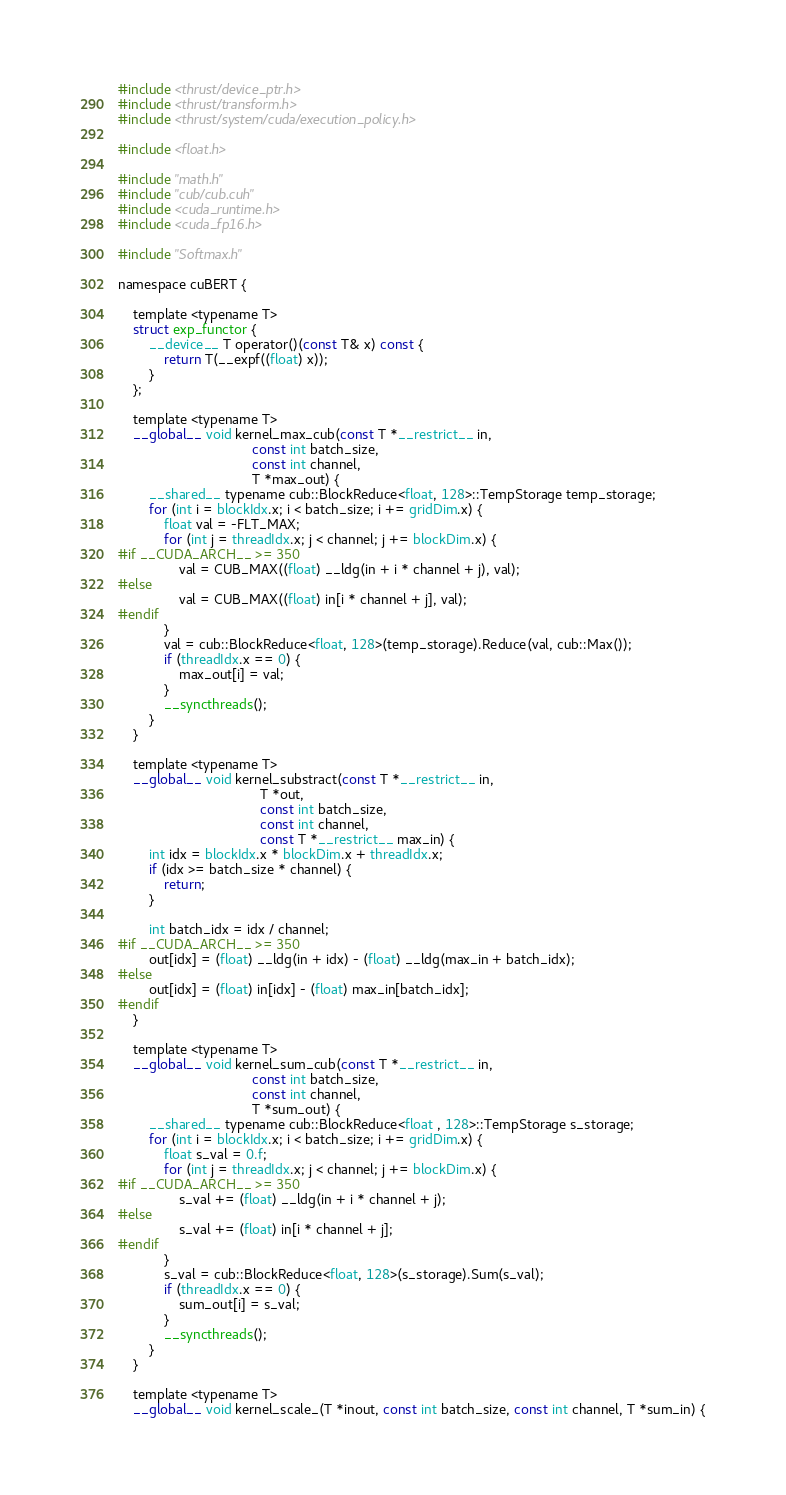<code> <loc_0><loc_0><loc_500><loc_500><_Cuda_>#include <thrust/device_ptr.h>
#include <thrust/transform.h>
#include <thrust/system/cuda/execution_policy.h>

#include <float.h>

#include "math.h"
#include "cub/cub.cuh"
#include <cuda_runtime.h>
#include <cuda_fp16.h>

#include "Softmax.h"

namespace cuBERT {

    template <typename T>
    struct exp_functor {
        __device__ T operator()(const T& x) const {
            return T(__expf((float) x));
        }
    };

    template <typename T>
    __global__ void kernel_max_cub(const T *__restrict__ in,
                                   const int batch_size,
                                   const int channel,
                                   T *max_out) {
        __shared__ typename cub::BlockReduce<float, 128>::TempStorage temp_storage;
        for (int i = blockIdx.x; i < batch_size; i += gridDim.x) {
            float val = -FLT_MAX;
            for (int j = threadIdx.x; j < channel; j += blockDim.x) {
#if __CUDA_ARCH__ >= 350
                val = CUB_MAX((float) __ldg(in + i * channel + j), val);
#else
                val = CUB_MAX((float) in[i * channel + j], val);
#endif
            }
            val = cub::BlockReduce<float, 128>(temp_storage).Reduce(val, cub::Max());
            if (threadIdx.x == 0) {
                max_out[i] = val;
            }
            __syncthreads();
        }
    }

    template <typename T>
    __global__ void kernel_substract(const T *__restrict__ in, 
                                     T *out, 
                                     const int batch_size, 
                                     const int channel, 
                                     const T *__restrict__ max_in) {
        int idx = blockIdx.x * blockDim.x + threadIdx.x;
        if (idx >= batch_size * channel) {
            return;
        }

        int batch_idx = idx / channel;
#if __CUDA_ARCH__ >= 350
        out[idx] = (float) __ldg(in + idx) - (float) __ldg(max_in + batch_idx);
#else
        out[idx] = (float) in[idx] - (float) max_in[batch_idx];
#endif
    }

    template <typename T>
    __global__ void kernel_sum_cub(const T *__restrict__ in,
                                   const int batch_size,
                                   const int channel,
                                   T *sum_out) {
        __shared__ typename cub::BlockReduce<float , 128>::TempStorage s_storage;
        for (int i = blockIdx.x; i < batch_size; i += gridDim.x) {
            float s_val = 0.f;
            for (int j = threadIdx.x; j < channel; j += blockDim.x) {
#if __CUDA_ARCH__ >= 350
                s_val += (float) __ldg(in + i * channel + j);
#else
                s_val += (float) in[i * channel + j];
#endif
            }
            s_val = cub::BlockReduce<float, 128>(s_storage).Sum(s_val);
            if (threadIdx.x == 0) {
                sum_out[i] = s_val;
            }
            __syncthreads();
        }
    }

    template <typename T>
    __global__ void kernel_scale_(T *inout, const int batch_size, const int channel, T *sum_in) {</code> 